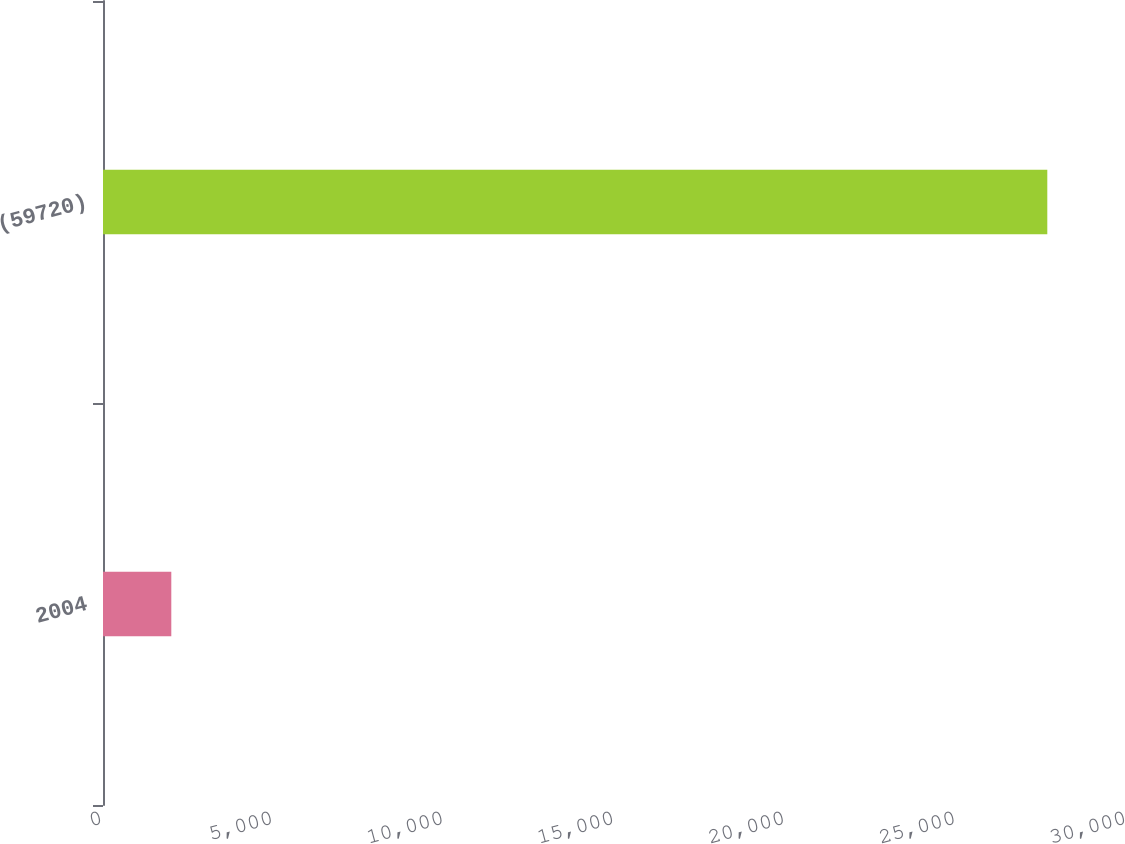Convert chart. <chart><loc_0><loc_0><loc_500><loc_500><bar_chart><fcel>2004<fcel>(59720)<nl><fcel>2001<fcel>27665<nl></chart> 